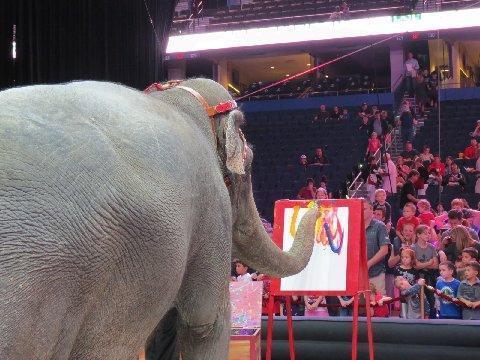How many elephants are painting?
Give a very brief answer. 1. How many elephants are visible?
Give a very brief answer. 1. How many orange lights are on the right side of the truck?
Give a very brief answer. 0. 